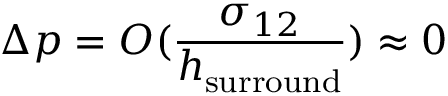<formula> <loc_0><loc_0><loc_500><loc_500>\Delta p = O ( \frac { \sigma _ { 1 2 } } { h _ { s u r r o u n d } } ) \approx 0</formula> 